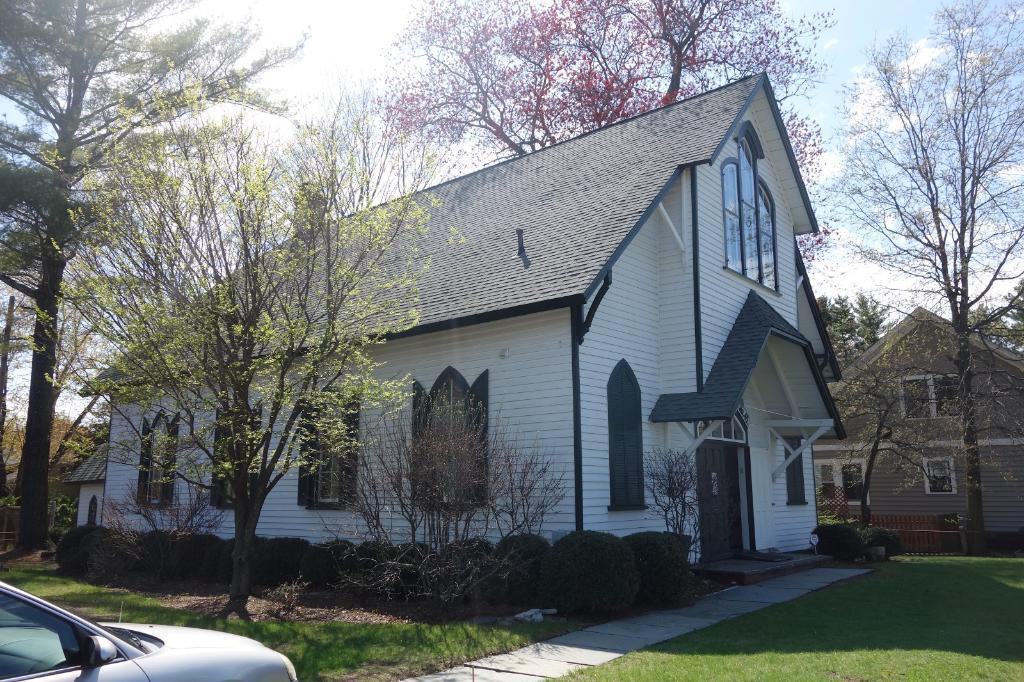How would you summarize this image in a sentence or two? In this image in the center there are two houses and some trees, plants. At the bottom there is grass walkway and one car, on the top of the image there is sky. 